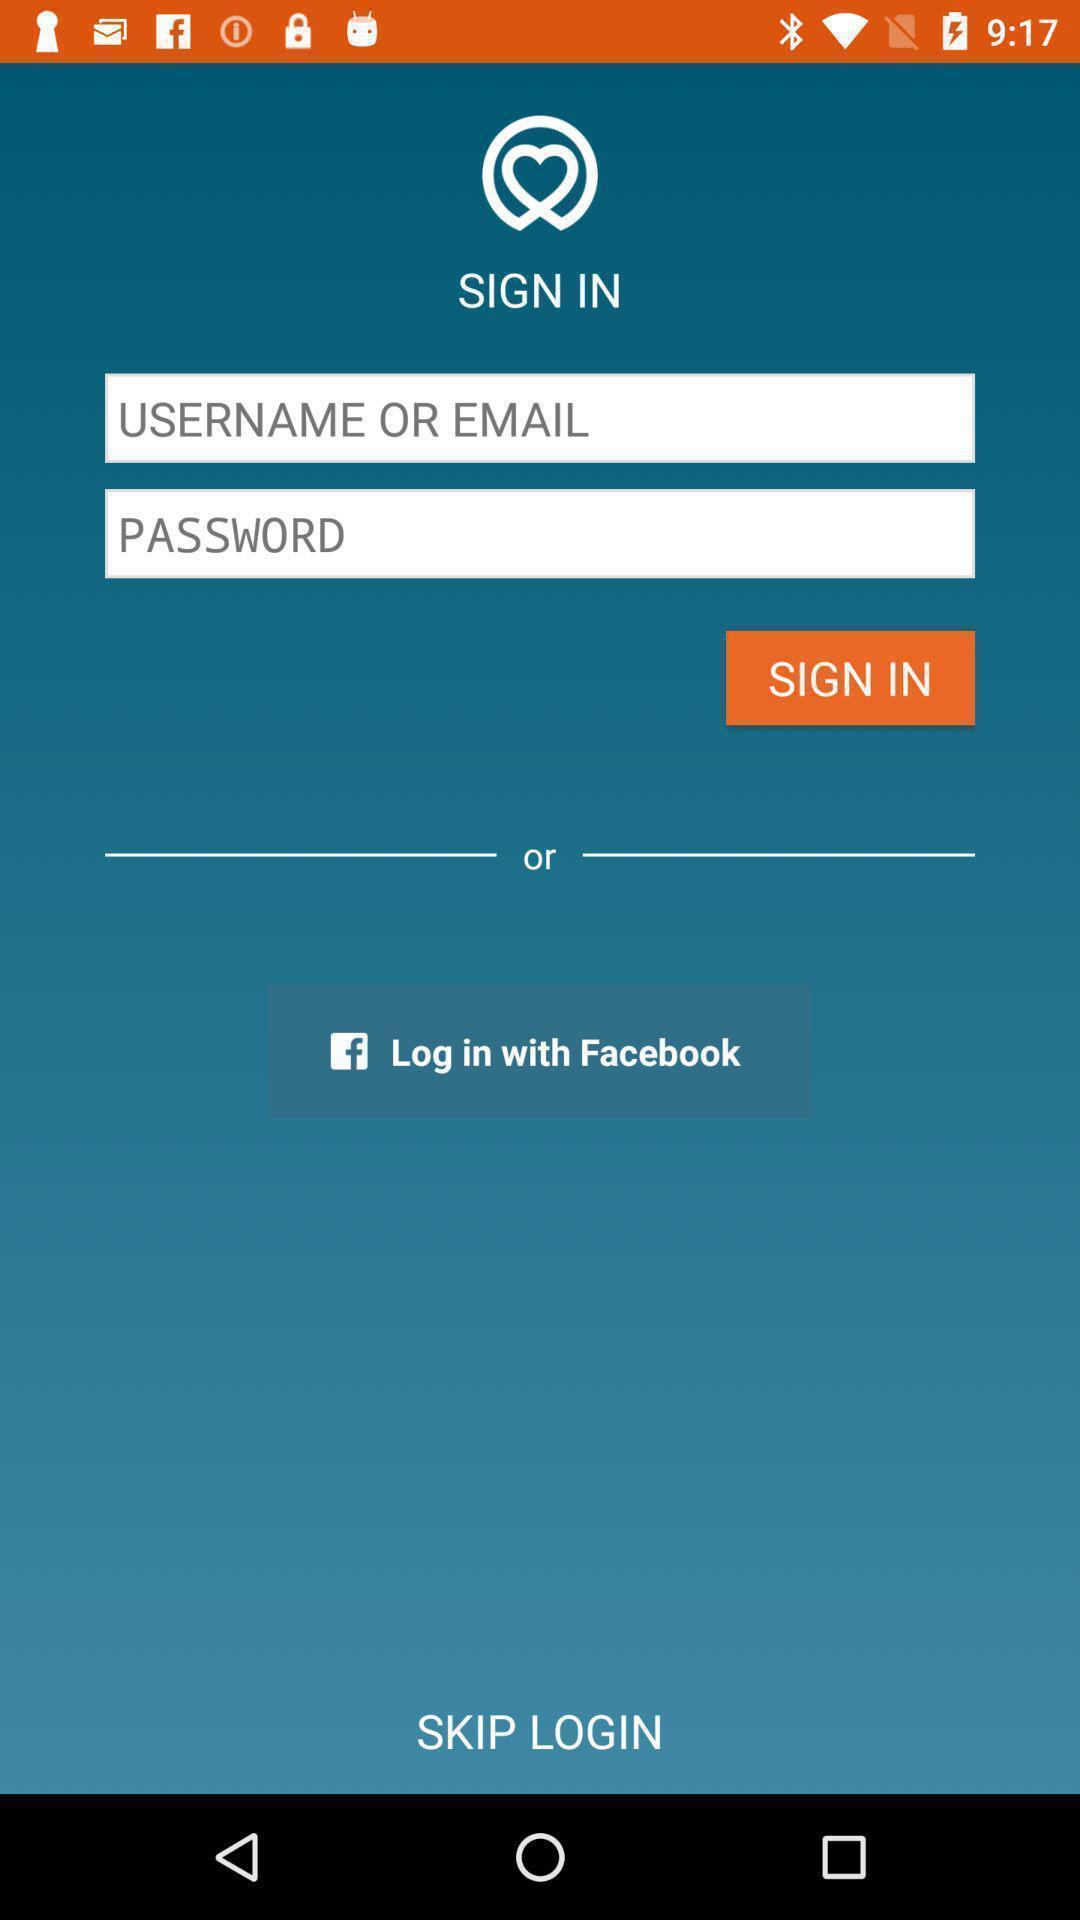Summarize the information in this screenshot. Sign in page. 